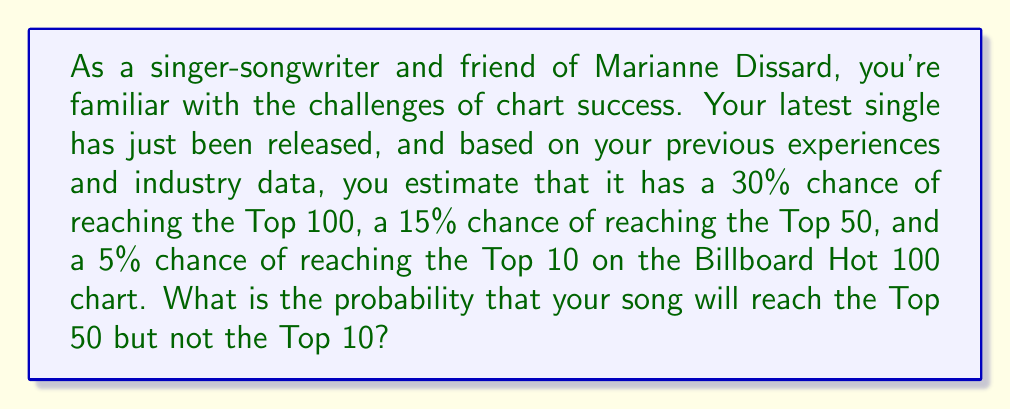Give your solution to this math problem. To solve this problem, we need to use the concept of conditional probability. We're looking for the probability of the song reaching the Top 50, but not the Top 10.

Let's define our events:
A: The song reaches the Top 100
B: The song reaches the Top 50
C: The song reaches the Top 10

We're given:
P(A) = 0.30
P(B) = 0.15
P(C) = 0.05

We want to find P(B and not C), which can be written as P(B ∩ C').

We can calculate this using the formula:
P(B ∩ C') = P(B) - P(C)

This works because reaching the Top 10 implies reaching the Top 50, so the probability of reaching the Top 50 but not the Top 10 is the difference between the probabilities of reaching these two positions.

Plugging in our values:

$$ P(B ∩ C') = P(B) - P(C) = 0.15 - 0.05 = 0.10 $$

Therefore, the probability that your song will reach the Top 50 but not the Top 10 is 0.10 or 10%.
Answer: The probability that the song will reach the Top 50 but not the Top 10 is 0.10 or 10%. 